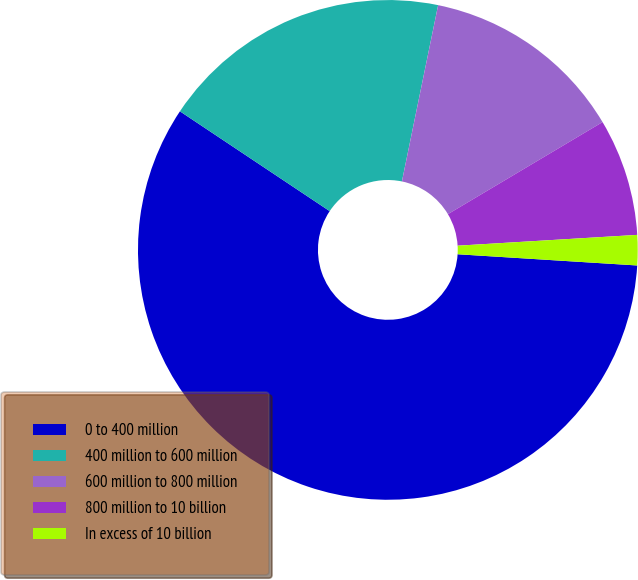Convert chart to OTSL. <chart><loc_0><loc_0><loc_500><loc_500><pie_chart><fcel>0 to 400 million<fcel>400 million to 600 million<fcel>600 million to 800 million<fcel>800 million to 10 billion<fcel>In excess of 10 billion<nl><fcel>58.37%<fcel>18.87%<fcel>13.23%<fcel>7.59%<fcel>1.95%<nl></chart> 